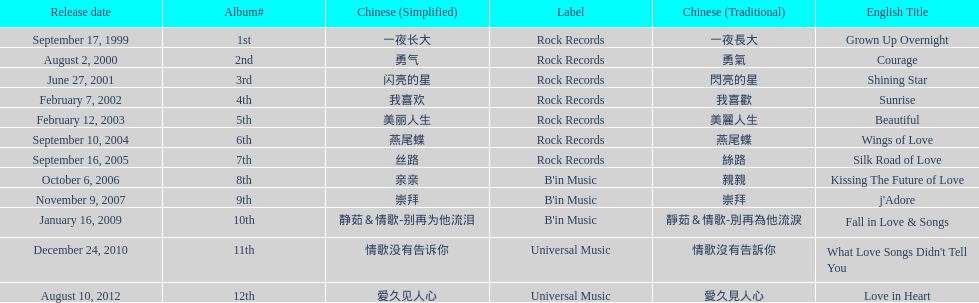What label was she working with before universal music? B'in Music. 